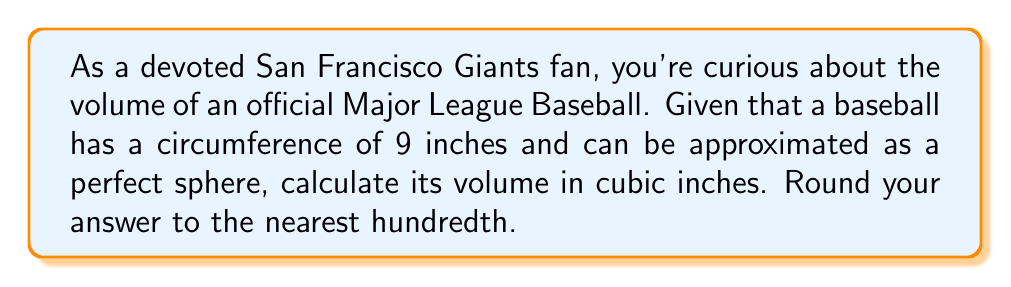Give your solution to this math problem. To find the volume of a baseball, we'll treat it as a perfect sphere. Let's approach this step-by-step:

1) First, we need to find the radius of the baseball. We're given the circumference, which is 9 inches.

   The formula for circumference is: $C = 2\pi r$

   Where $C$ is circumference and $r$ is radius.

2) We can rearrange this to solve for $r$:

   $r = \frac{C}{2\pi}$

3) Plugging in our value for $C$:

   $r = \frac{9}{2\pi} \approx 1.4325$ inches

4) Now that we have the radius, we can use the formula for the volume of a sphere:

   $V = \frac{4}{3}\pi r^3$

5) Substituting our value for $r$:

   $V = \frac{4}{3}\pi (1.4325)^3$

6) Let's calculate this:

   $V = \frac{4}{3} \cdot \pi \cdot 2.9397$
   $V = 4.1888 \cdot 2.9397$
   $V = 12.3132$ cubic inches

7) Rounding to the nearest hundredth:

   $V \approx 12.31$ cubic inches

This volume is equivalent to about 201.72 milliliters, which is just about the right size to fit comfortably in the hand of a Giants pitcher!
Answer: $12.31$ cubic inches 